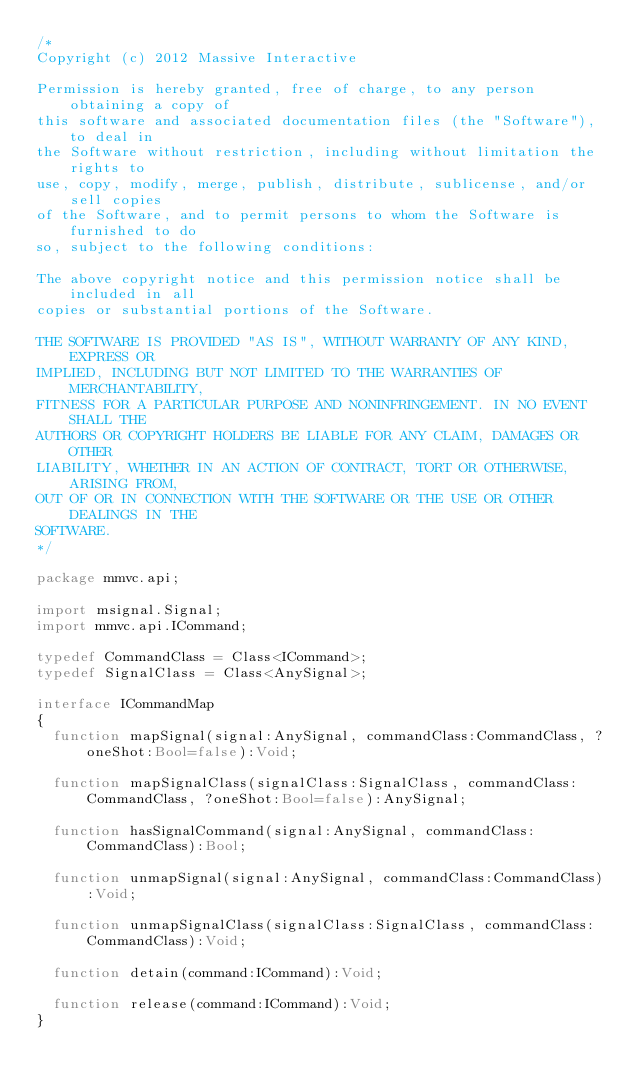<code> <loc_0><loc_0><loc_500><loc_500><_Haxe_>/*
Copyright (c) 2012 Massive Interactive

Permission is hereby granted, free of charge, to any person obtaining a copy of 
this software and associated documentation files (the "Software"), to deal in 
the Software without restriction, including without limitation the rights to 
use, copy, modify, merge, publish, distribute, sublicense, and/or sell copies 
of the Software, and to permit persons to whom the Software is furnished to do 
so, subject to the following conditions:

The above copyright notice and this permission notice shall be included in all 
copies or substantial portions of the Software.

THE SOFTWARE IS PROVIDED "AS IS", WITHOUT WARRANTY OF ANY KIND, EXPRESS OR 
IMPLIED, INCLUDING BUT NOT LIMITED TO THE WARRANTIES OF MERCHANTABILITY, 
FITNESS FOR A PARTICULAR PURPOSE AND NONINFRINGEMENT. IN NO EVENT SHALL THE 
AUTHORS OR COPYRIGHT HOLDERS BE LIABLE FOR ANY CLAIM, DAMAGES OR OTHER 
LIABILITY, WHETHER IN AN ACTION OF CONTRACT, TORT OR OTHERWISE, ARISING FROM, 
OUT OF OR IN CONNECTION WITH THE SOFTWARE OR THE USE OR OTHER DEALINGS IN THE 
SOFTWARE.
*/

package mmvc.api;

import msignal.Signal;
import mmvc.api.ICommand;

typedef CommandClass = Class<ICommand>;
typedef SignalClass = Class<AnySignal>;

interface ICommandMap
{
	function mapSignal(signal:AnySignal, commandClass:CommandClass, ?oneShot:Bool=false):Void;

	function mapSignalClass(signalClass:SignalClass, commandClass:CommandClass, ?oneShot:Bool=false):AnySignal;

	function hasSignalCommand(signal:AnySignal, commandClass:CommandClass):Bool;

	function unmapSignal(signal:AnySignal, commandClass:CommandClass):Void;

	function unmapSignalClass(signalClass:SignalClass, commandClass:CommandClass):Void;

	function detain(command:ICommand):Void;

	function release(command:ICommand):Void;
}
</code> 